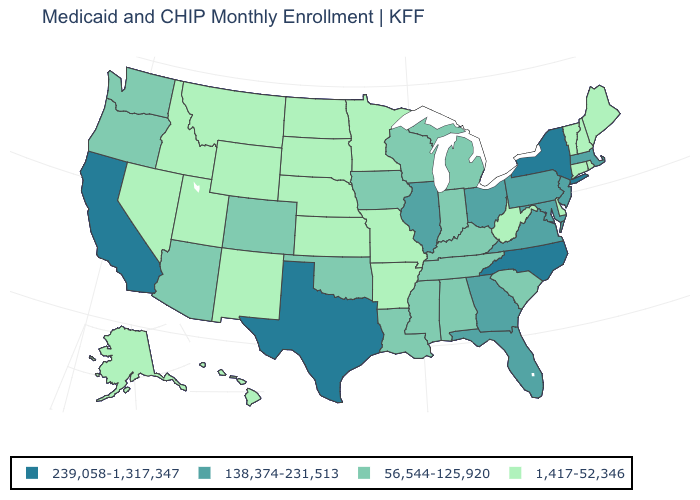How many symbols are there in the legend?
Write a very short answer. 4. Which states have the highest value in the USA?
Keep it brief. California, New York, North Carolina, Texas. What is the value of Oklahoma?
Short answer required. 56,544-125,920. What is the value of Maryland?
Give a very brief answer. 138,374-231,513. Does Colorado have a lower value than Maryland?
Answer briefly. Yes. Which states have the highest value in the USA?
Quick response, please. California, New York, North Carolina, Texas. Does Nebraska have the lowest value in the USA?
Short answer required. Yes. What is the lowest value in the USA?
Write a very short answer. 1,417-52,346. What is the value of South Dakota?
Keep it brief. 1,417-52,346. What is the lowest value in the MidWest?
Give a very brief answer. 1,417-52,346. Does Connecticut have the lowest value in the Northeast?
Quick response, please. Yes. Name the states that have a value in the range 1,417-52,346?
Short answer required. Alaska, Arkansas, Connecticut, Delaware, Hawaii, Idaho, Kansas, Maine, Minnesota, Missouri, Montana, Nebraska, Nevada, New Hampshire, New Mexico, North Dakota, Rhode Island, South Dakota, Utah, Vermont, West Virginia, Wyoming. What is the value of Kansas?
Concise answer only. 1,417-52,346. What is the value of Wisconsin?
Short answer required. 56,544-125,920. 